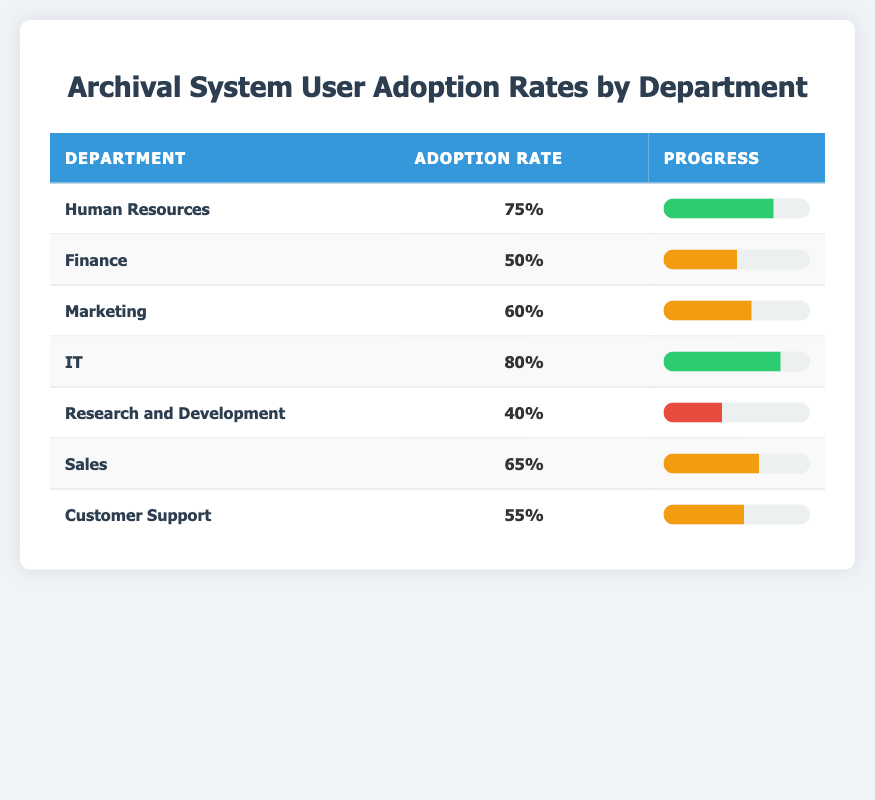What is the adoption rate for the IT department? The table indicates that the adoption rate specifically for the IT department is listed as 80%.
Answer: 80% Which department has the lowest user adoption rate? By comparing all the adoption rates in the table, Research and Development has the lowest rate at 40%.
Answer: Research and Development What is the average adoption rate across all departments? We add the adoption rates: (75 + 50 + 60 + 80 + 40 + 65 + 55) = 425. There are 7 departments, so we divide 425 by 7 which gives us approximately 60.71.
Answer: 60.71 Is the adoption rate for Human Resources above 70%? The adoption rate for Human Resources is shown as 75%, which is indeed above 70%.
Answer: Yes Which two departments have adoption rates above 60%? Reviewing the table shows that IT (80%) and Human Resources (75%) are the only two departments with adoption rates above 60%.
Answer: IT and Human Resources What is the difference in adoption rates between the highest and lowest departments? The highest adoption rate is from IT at 80% and the lowest from Research and Development at 40%. The difference is 80 - 40 = 40%.
Answer: 40% What percentage of departments have an adoption rate of 60% or higher? The departments with rates of 60% or higher are IT, Human Resources, and Marketing, which totals 3 out of 7 departments. This means the percentage is (3/7) * 100, resulting in about 42.86%.
Answer: 42.86% Is the adoption rate of Marketing higher than that of Finance? Looking at the table, Marketing has an adoption rate of 60% while Finance has 50%. Since 60% is greater than 50%, the answer is true.
Answer: Yes 